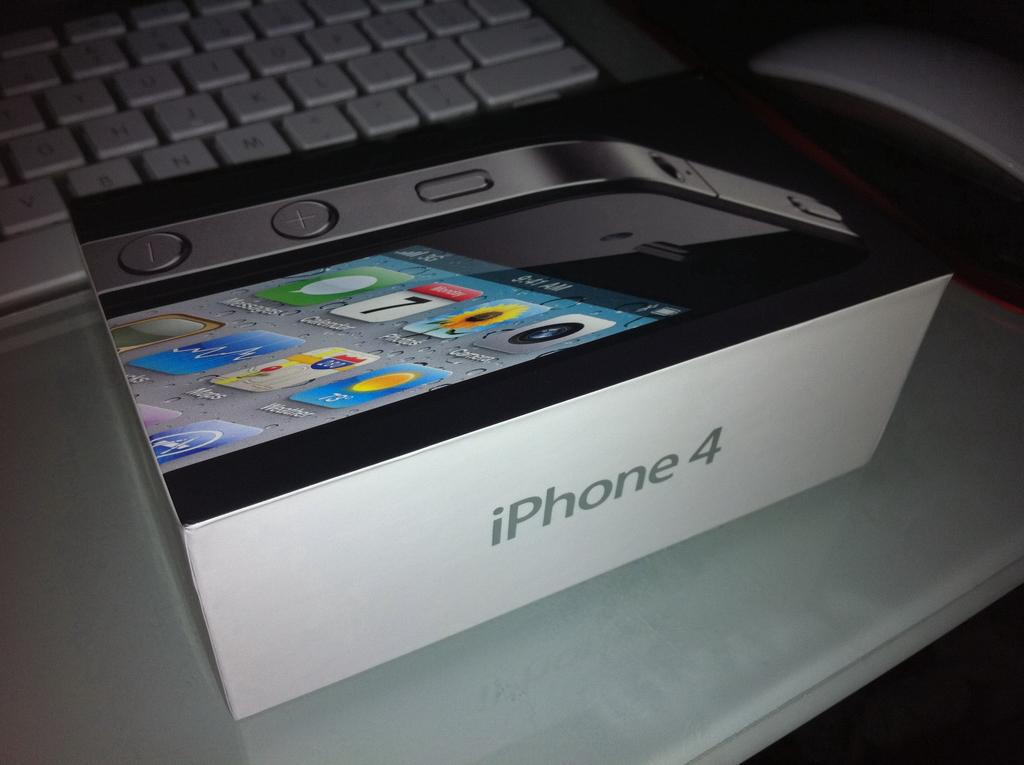<image>
Describe the image concisely. A brand new iPhone 4 box sitting in front of a keyboard. 